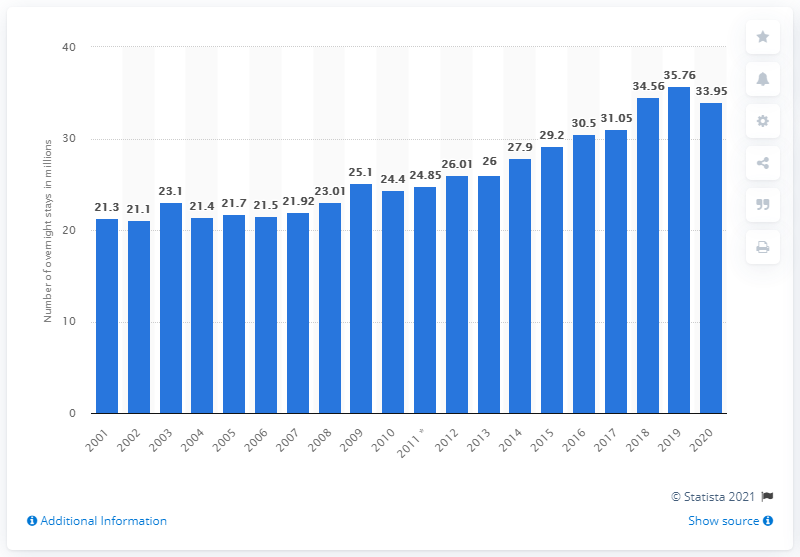Specify some key components in this picture. In 2020, a total of 33.95 nights were spent at German camping sites. 